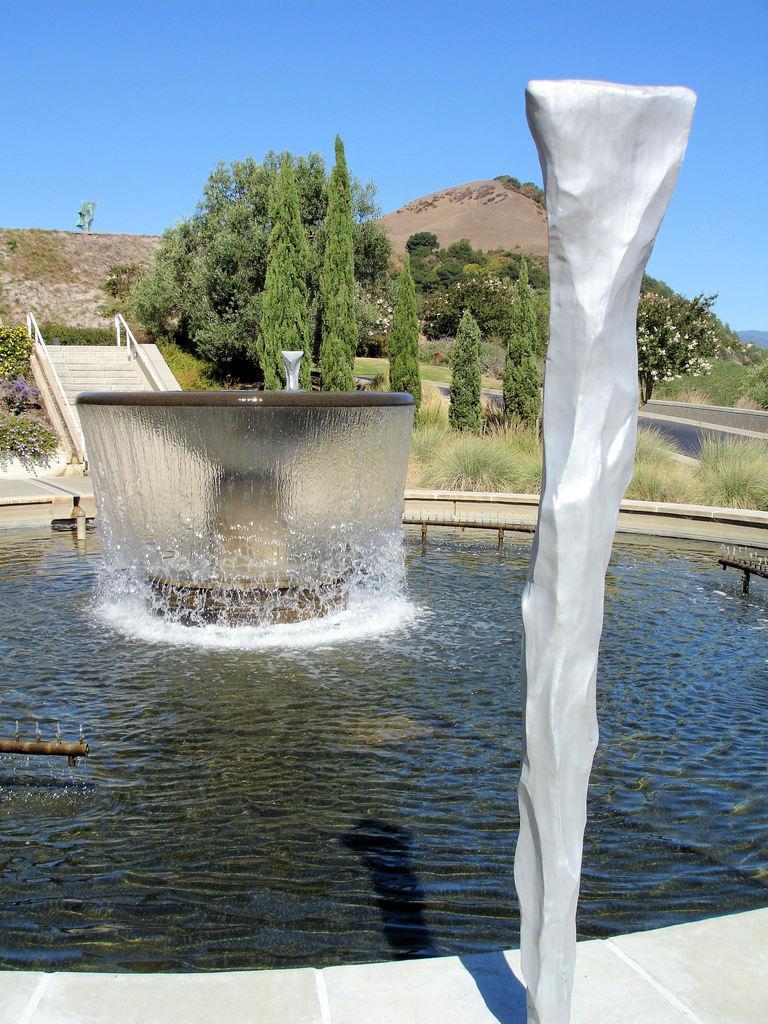Please provide a concise description of this image. In this picture I can see a fountain in the middle, on the left side there is the staircase, in the background there are trees. On the right side it looks like a pillar, at the top I can see the sky. 